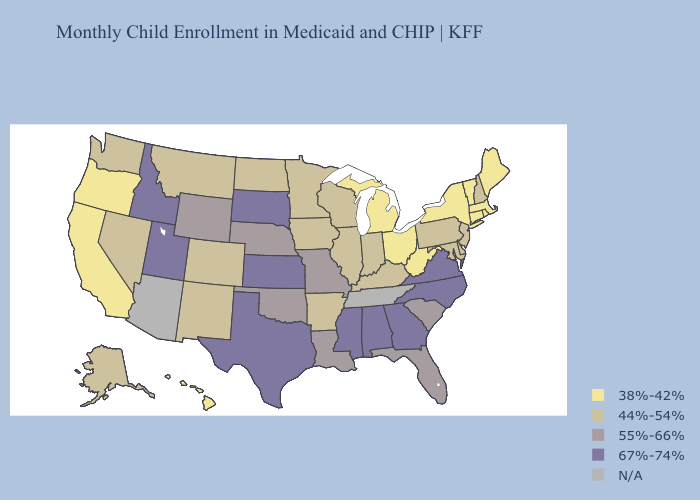Name the states that have a value in the range 67%-74%?
Be succinct. Alabama, Georgia, Idaho, Kansas, Mississippi, North Carolina, South Dakota, Texas, Utah, Virginia. What is the lowest value in states that border Georgia?
Concise answer only. 55%-66%. What is the lowest value in states that border North Dakota?
Short answer required. 44%-54%. What is the lowest value in the USA?
Be succinct. 38%-42%. What is the highest value in the Northeast ?
Keep it brief. 44%-54%. What is the highest value in the Northeast ?
Keep it brief. 44%-54%. Name the states that have a value in the range 55%-66%?
Write a very short answer. Florida, Louisiana, Missouri, Nebraska, Oklahoma, South Carolina, Wyoming. Does Kansas have the highest value in the USA?
Concise answer only. Yes. Name the states that have a value in the range 44%-54%?
Answer briefly. Alaska, Arkansas, Colorado, Delaware, Illinois, Indiana, Iowa, Kentucky, Maryland, Minnesota, Montana, Nevada, New Hampshire, New Jersey, New Mexico, North Dakota, Pennsylvania, Washington, Wisconsin. What is the value of Iowa?
Answer briefly. 44%-54%. Name the states that have a value in the range N/A?
Concise answer only. Arizona, Tennessee. Is the legend a continuous bar?
Quick response, please. No. Name the states that have a value in the range 44%-54%?
Be succinct. Alaska, Arkansas, Colorado, Delaware, Illinois, Indiana, Iowa, Kentucky, Maryland, Minnesota, Montana, Nevada, New Hampshire, New Jersey, New Mexico, North Dakota, Pennsylvania, Washington, Wisconsin. 